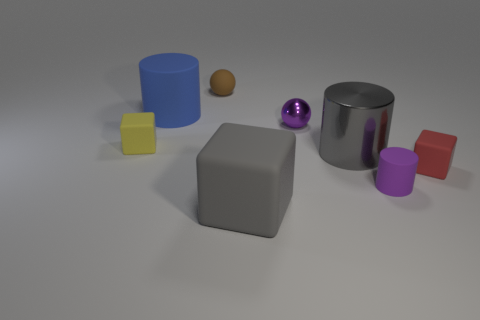Add 1 blue rubber balls. How many objects exist? 9 Subtract all spheres. How many objects are left? 6 Subtract 0 yellow cylinders. How many objects are left? 8 Subtract all gray shiny things. Subtract all purple matte objects. How many objects are left? 6 Add 2 gray cubes. How many gray cubes are left? 3 Add 1 gray matte cylinders. How many gray matte cylinders exist? 1 